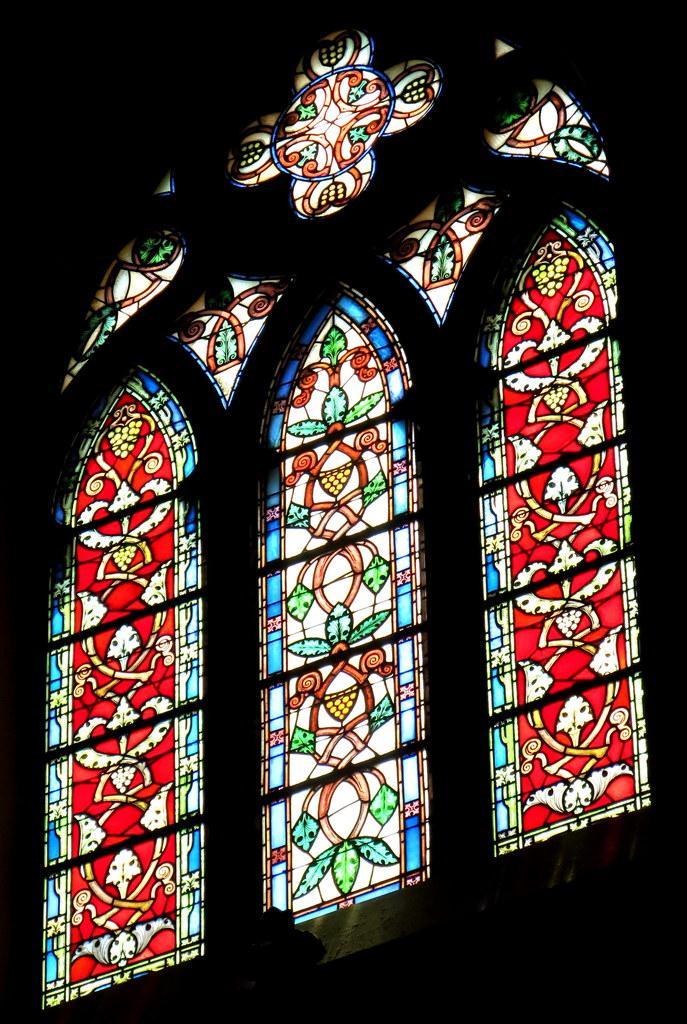In one or two sentences, can you explain what this image depicts? In this picture we can see stained glasses, there is a dark background. 